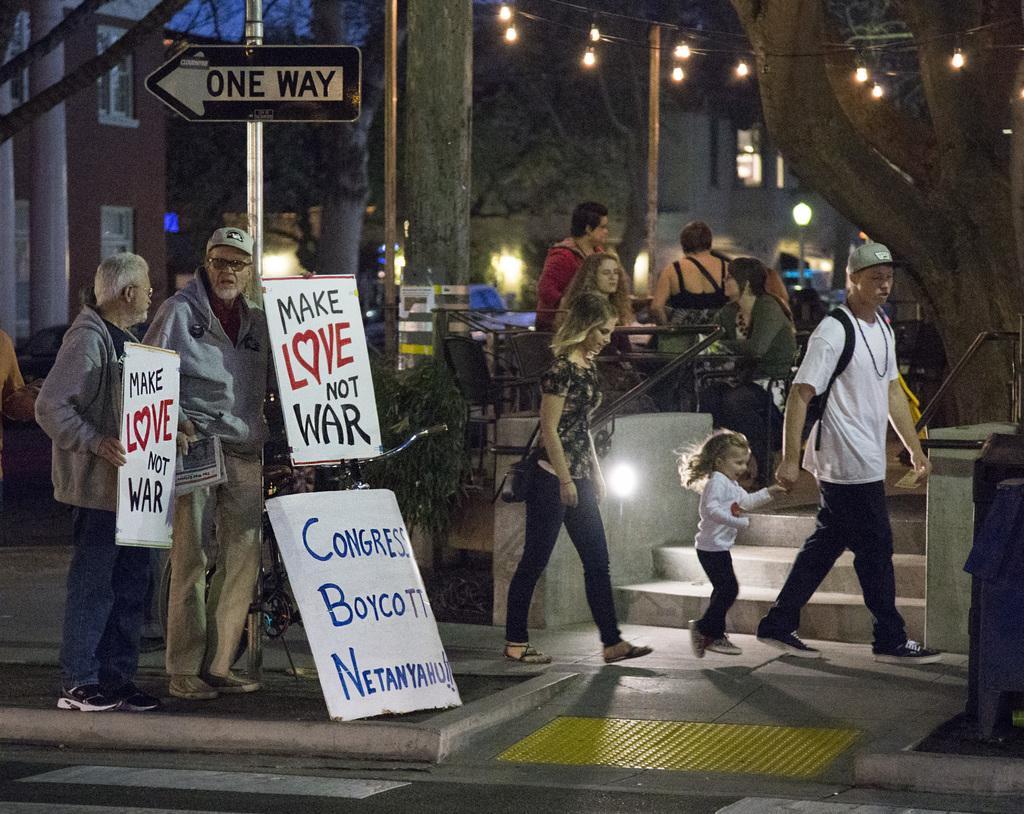How would you summarize this image in a sentence or two? In the image I can see people among them the people on the left side are holding placards in hands. In the background I can see some people are sitting on chairs in front of tables. I can also see sign boards, string lights, poles, buildings, trees, steps and some other objects on the ground. 